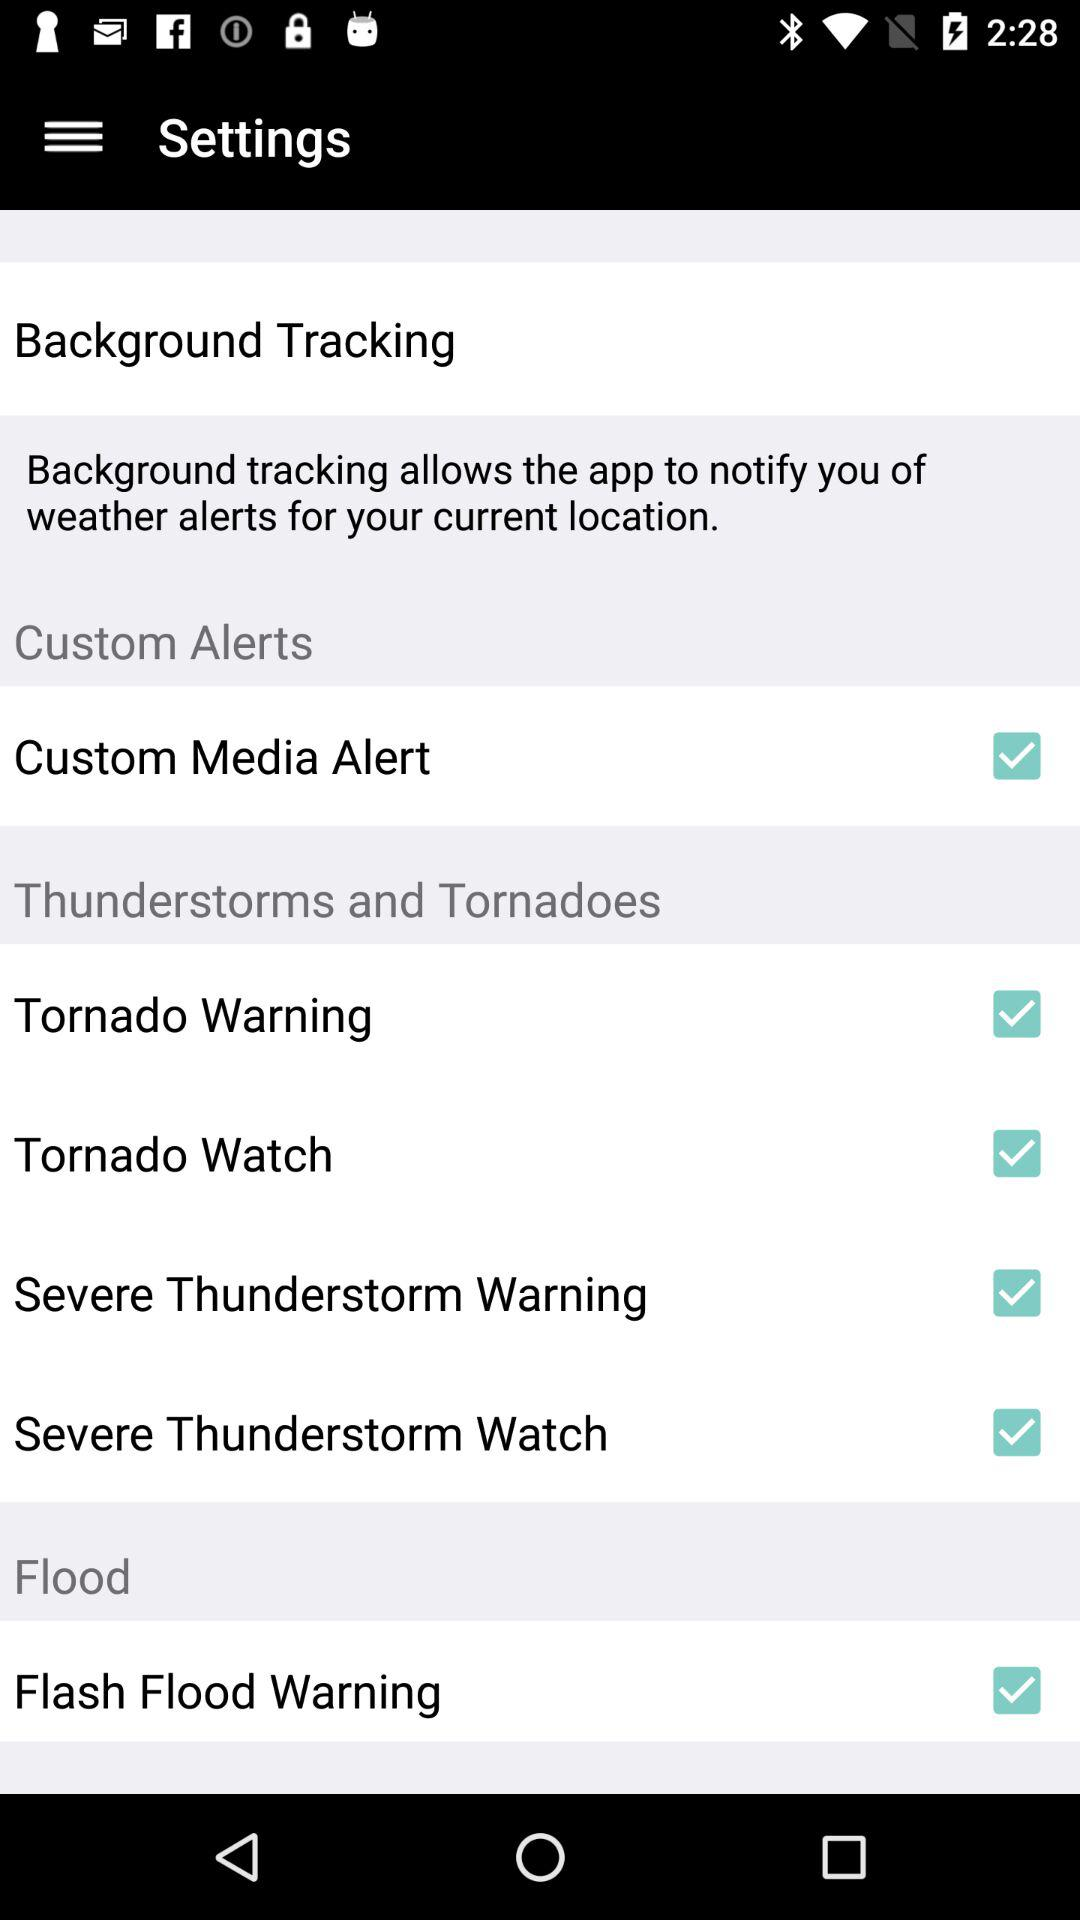What is the status of "Custom Media Alert"? The status of "Custom Media Alert" is "on". 